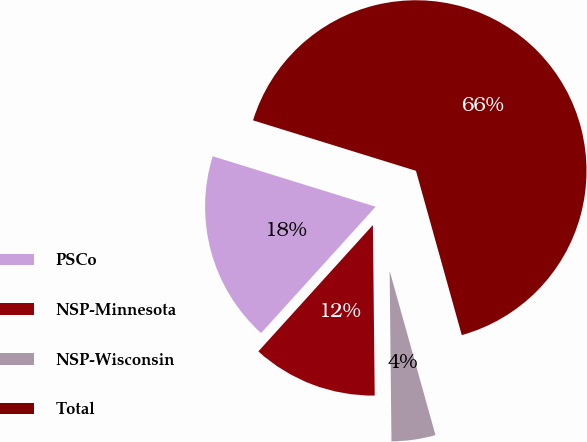Convert chart. <chart><loc_0><loc_0><loc_500><loc_500><pie_chart><fcel>PSCo<fcel>NSP-Minnesota<fcel>NSP-Wisconsin<fcel>Total<nl><fcel>18.06%<fcel>11.89%<fcel>4.16%<fcel>65.89%<nl></chart> 